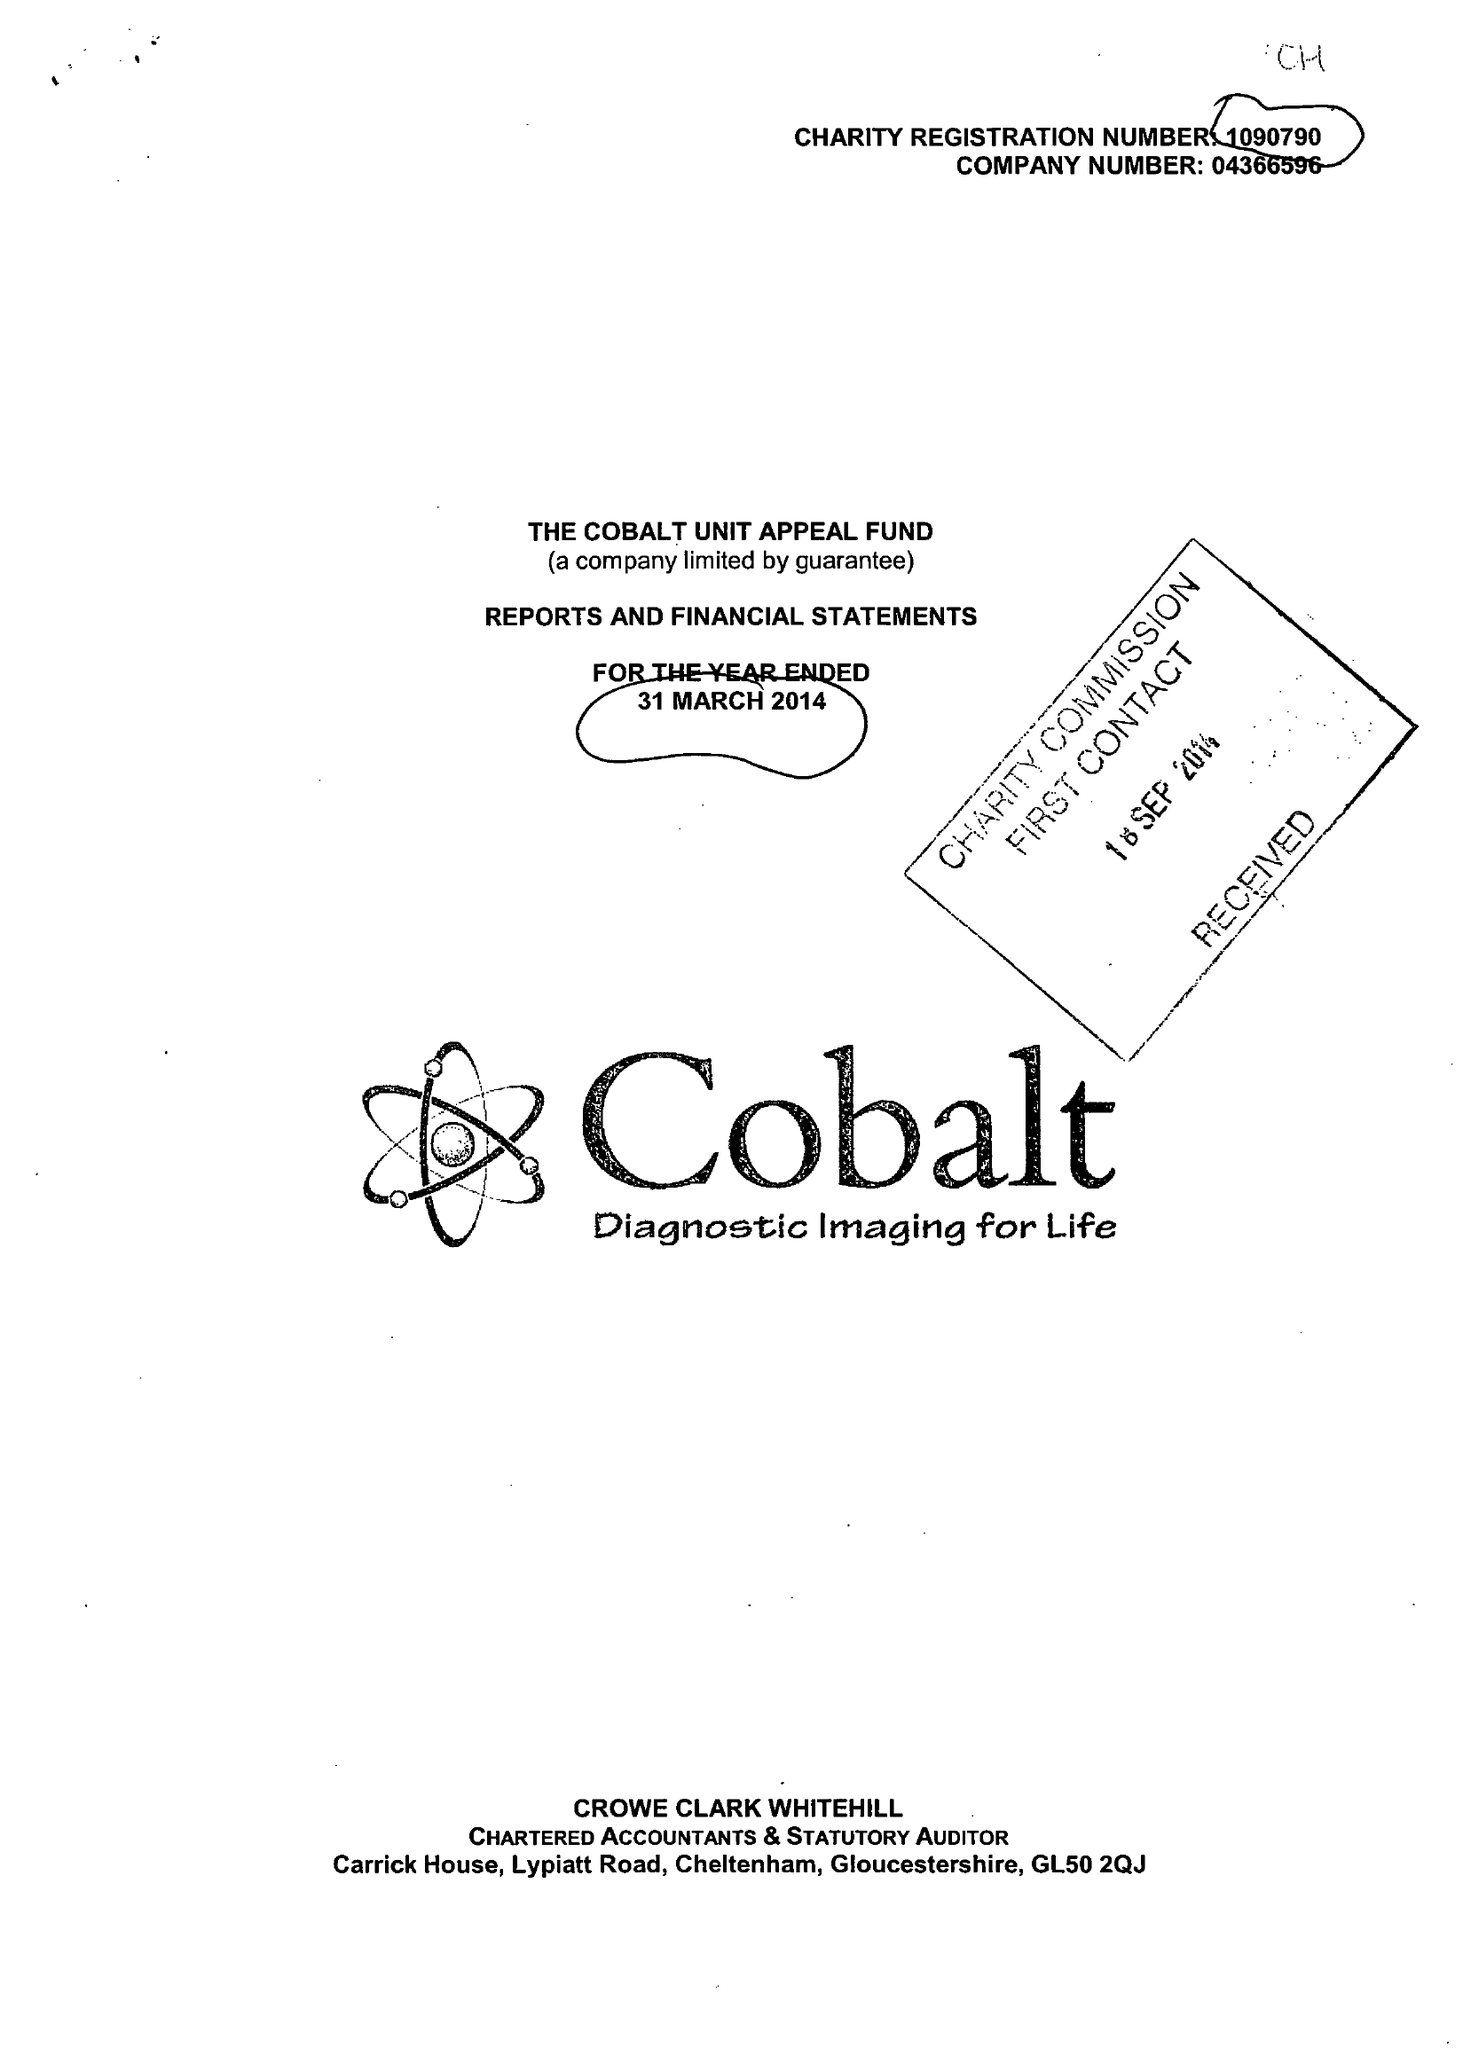What is the value for the address__street_line?
Answer the question using a single word or phrase. THIRLESTAINE ROAD 